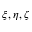Convert formula to latex. <formula><loc_0><loc_0><loc_500><loc_500>\xi , \eta , \zeta</formula> 